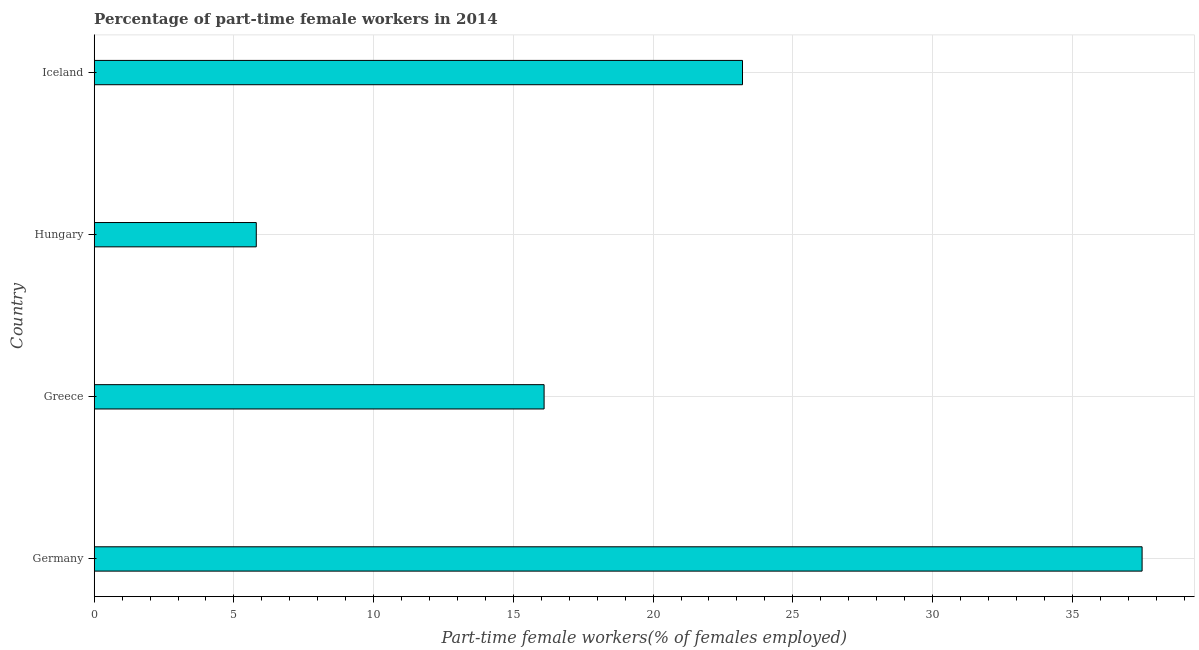Does the graph contain any zero values?
Give a very brief answer. No. Does the graph contain grids?
Ensure brevity in your answer.  Yes. What is the title of the graph?
Make the answer very short. Percentage of part-time female workers in 2014. What is the label or title of the X-axis?
Provide a short and direct response. Part-time female workers(% of females employed). What is the label or title of the Y-axis?
Ensure brevity in your answer.  Country. What is the percentage of part-time female workers in Iceland?
Your answer should be very brief. 23.2. Across all countries, what is the maximum percentage of part-time female workers?
Make the answer very short. 37.5. Across all countries, what is the minimum percentage of part-time female workers?
Make the answer very short. 5.8. In which country was the percentage of part-time female workers maximum?
Your response must be concise. Germany. In which country was the percentage of part-time female workers minimum?
Provide a succinct answer. Hungary. What is the sum of the percentage of part-time female workers?
Offer a terse response. 82.6. What is the difference between the percentage of part-time female workers in Germany and Hungary?
Your answer should be compact. 31.7. What is the average percentage of part-time female workers per country?
Provide a short and direct response. 20.65. What is the median percentage of part-time female workers?
Ensure brevity in your answer.  19.65. In how many countries, is the percentage of part-time female workers greater than 23 %?
Keep it short and to the point. 2. What is the ratio of the percentage of part-time female workers in Greece to that in Hungary?
Keep it short and to the point. 2.78. What is the difference between the highest and the second highest percentage of part-time female workers?
Offer a terse response. 14.3. Is the sum of the percentage of part-time female workers in Greece and Hungary greater than the maximum percentage of part-time female workers across all countries?
Offer a very short reply. No. What is the difference between the highest and the lowest percentage of part-time female workers?
Offer a very short reply. 31.7. Are the values on the major ticks of X-axis written in scientific E-notation?
Ensure brevity in your answer.  No. What is the Part-time female workers(% of females employed) in Germany?
Your answer should be compact. 37.5. What is the Part-time female workers(% of females employed) of Greece?
Offer a very short reply. 16.1. What is the Part-time female workers(% of females employed) of Hungary?
Give a very brief answer. 5.8. What is the Part-time female workers(% of females employed) in Iceland?
Ensure brevity in your answer.  23.2. What is the difference between the Part-time female workers(% of females employed) in Germany and Greece?
Offer a terse response. 21.4. What is the difference between the Part-time female workers(% of females employed) in Germany and Hungary?
Ensure brevity in your answer.  31.7. What is the difference between the Part-time female workers(% of females employed) in Greece and Iceland?
Offer a terse response. -7.1. What is the difference between the Part-time female workers(% of females employed) in Hungary and Iceland?
Offer a very short reply. -17.4. What is the ratio of the Part-time female workers(% of females employed) in Germany to that in Greece?
Your response must be concise. 2.33. What is the ratio of the Part-time female workers(% of females employed) in Germany to that in Hungary?
Ensure brevity in your answer.  6.47. What is the ratio of the Part-time female workers(% of females employed) in Germany to that in Iceland?
Ensure brevity in your answer.  1.62. What is the ratio of the Part-time female workers(% of females employed) in Greece to that in Hungary?
Your response must be concise. 2.78. What is the ratio of the Part-time female workers(% of females employed) in Greece to that in Iceland?
Keep it short and to the point. 0.69. 